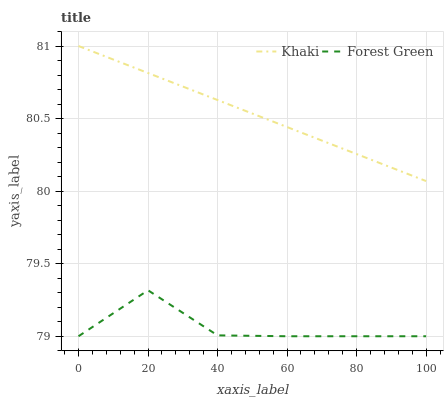Does Forest Green have the minimum area under the curve?
Answer yes or no. Yes. Does Khaki have the maximum area under the curve?
Answer yes or no. Yes. Does Khaki have the minimum area under the curve?
Answer yes or no. No. Is Khaki the smoothest?
Answer yes or no. Yes. Is Forest Green the roughest?
Answer yes or no. Yes. Is Khaki the roughest?
Answer yes or no. No. Does Forest Green have the lowest value?
Answer yes or no. Yes. Does Khaki have the lowest value?
Answer yes or no. No. Does Khaki have the highest value?
Answer yes or no. Yes. Is Forest Green less than Khaki?
Answer yes or no. Yes. Is Khaki greater than Forest Green?
Answer yes or no. Yes. Does Forest Green intersect Khaki?
Answer yes or no. No. 